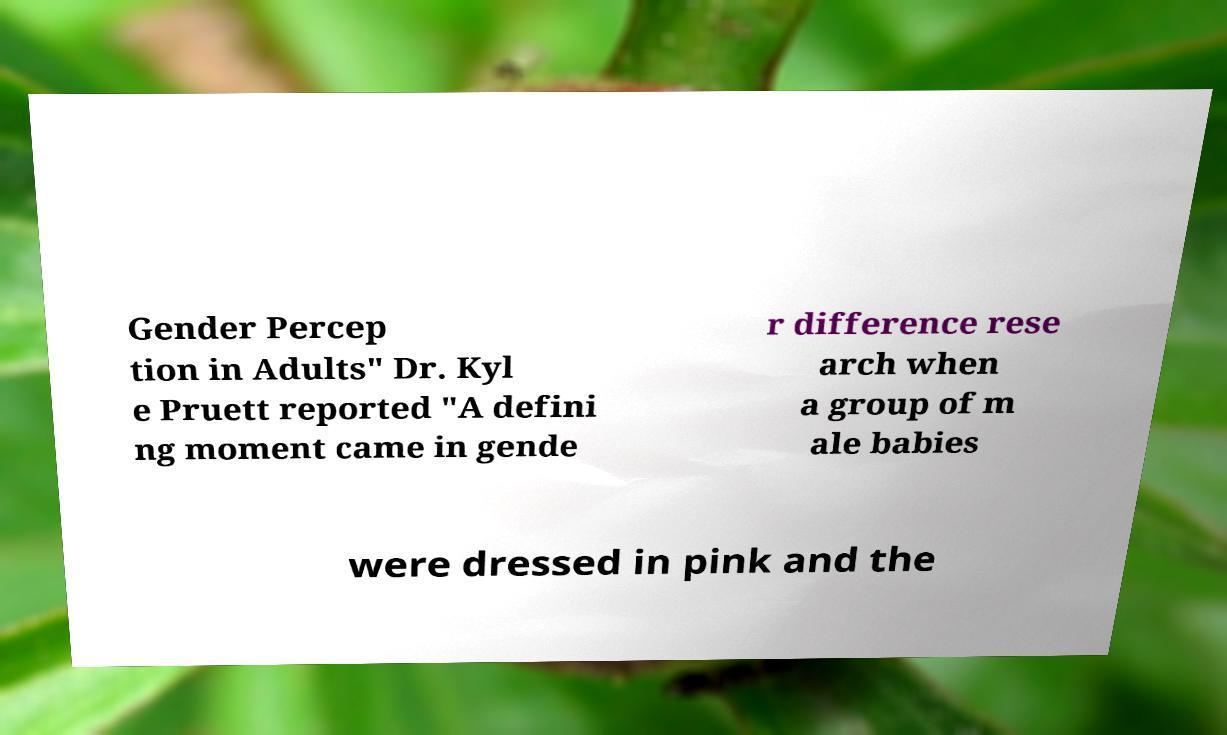Please identify and transcribe the text found in this image. Gender Percep tion in Adults" Dr. Kyl e Pruett reported "A defini ng moment came in gende r difference rese arch when a group of m ale babies were dressed in pink and the 